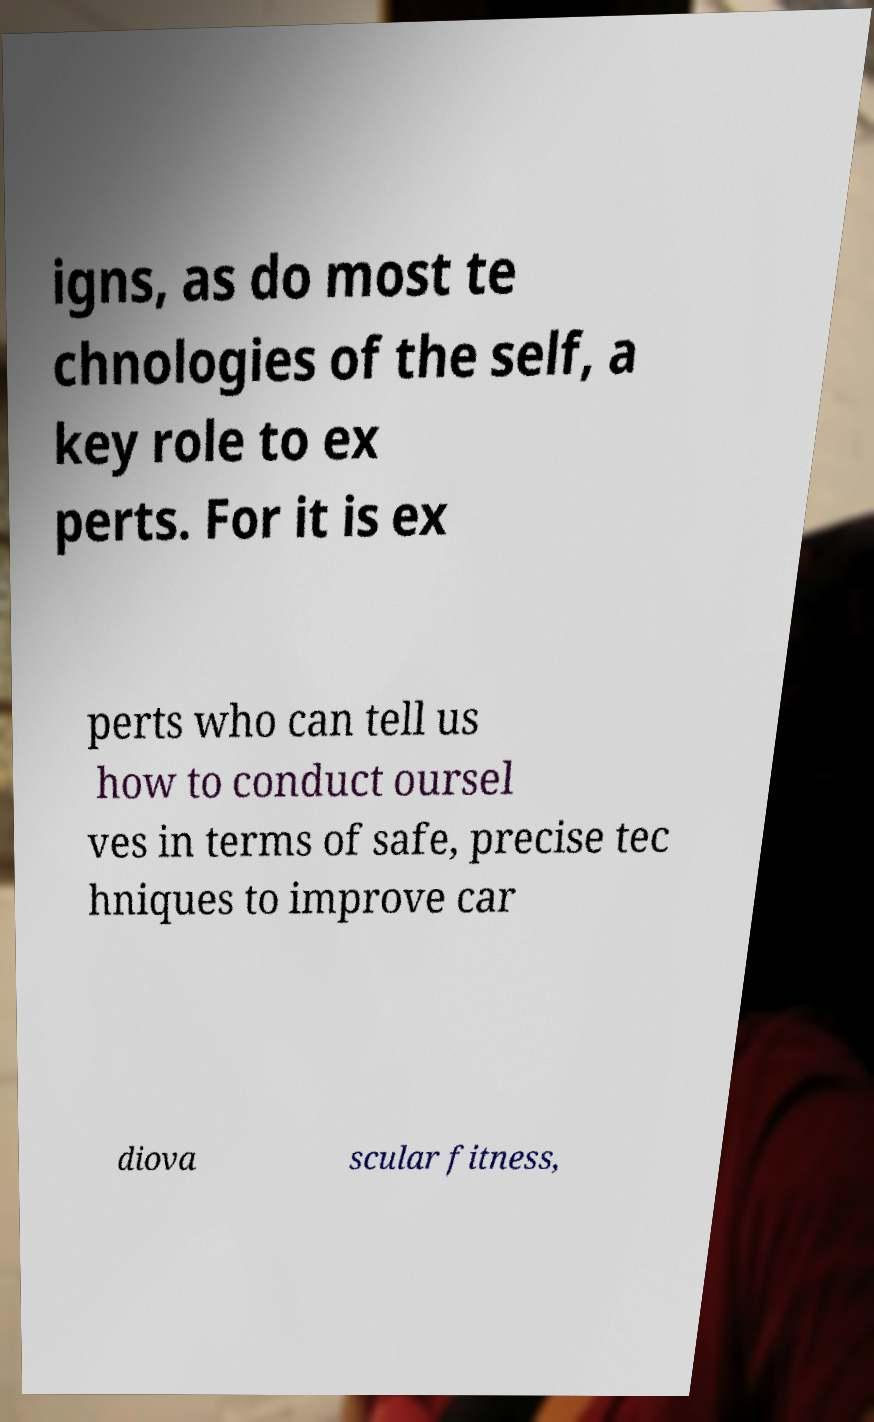Can you read and provide the text displayed in the image?This photo seems to have some interesting text. Can you extract and type it out for me? igns, as do most te chnologies of the self, a key role to ex perts. For it is ex perts who can tell us how to conduct oursel ves in terms of safe, precise tec hniques to improve car diova scular fitness, 